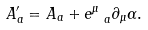<formula> <loc_0><loc_0><loc_500><loc_500>A _ { a } ^ { \prime } = A _ { a } + e ^ { \mu } _ { \ a } \partial _ { \mu } \alpha .</formula> 